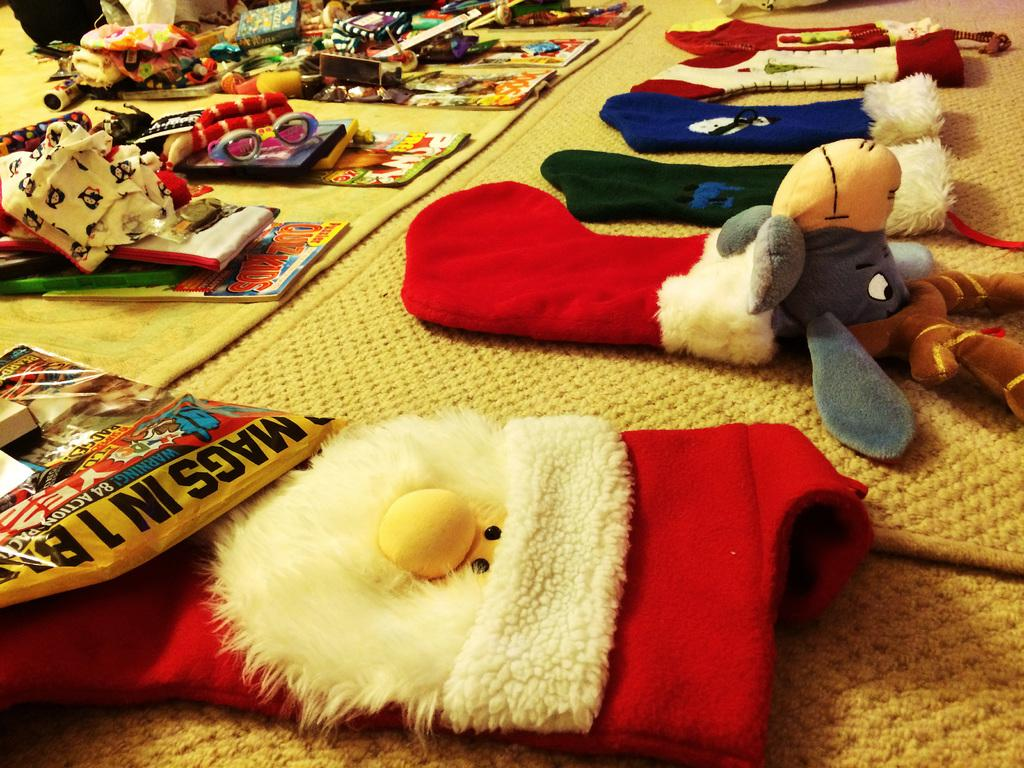What type of clothing items can be seen in the image? There are clothes visible in the image. What other items are related to Christmas in the image? There are Christmas socks in the image. What type of toy is present in the image? There is a soft toy in the image. What can be found on the floor in the image? Gifts are present on the floor in the image. What type of flooring is visible in the image? There are carpets on the floor in the image. Where is the secretary located in the image? There is no secretary present in the image. What type of trucks can be seen driving through the room in the image? There are no trucks visible in the image; it is an indoor scene with Christmas decorations. 